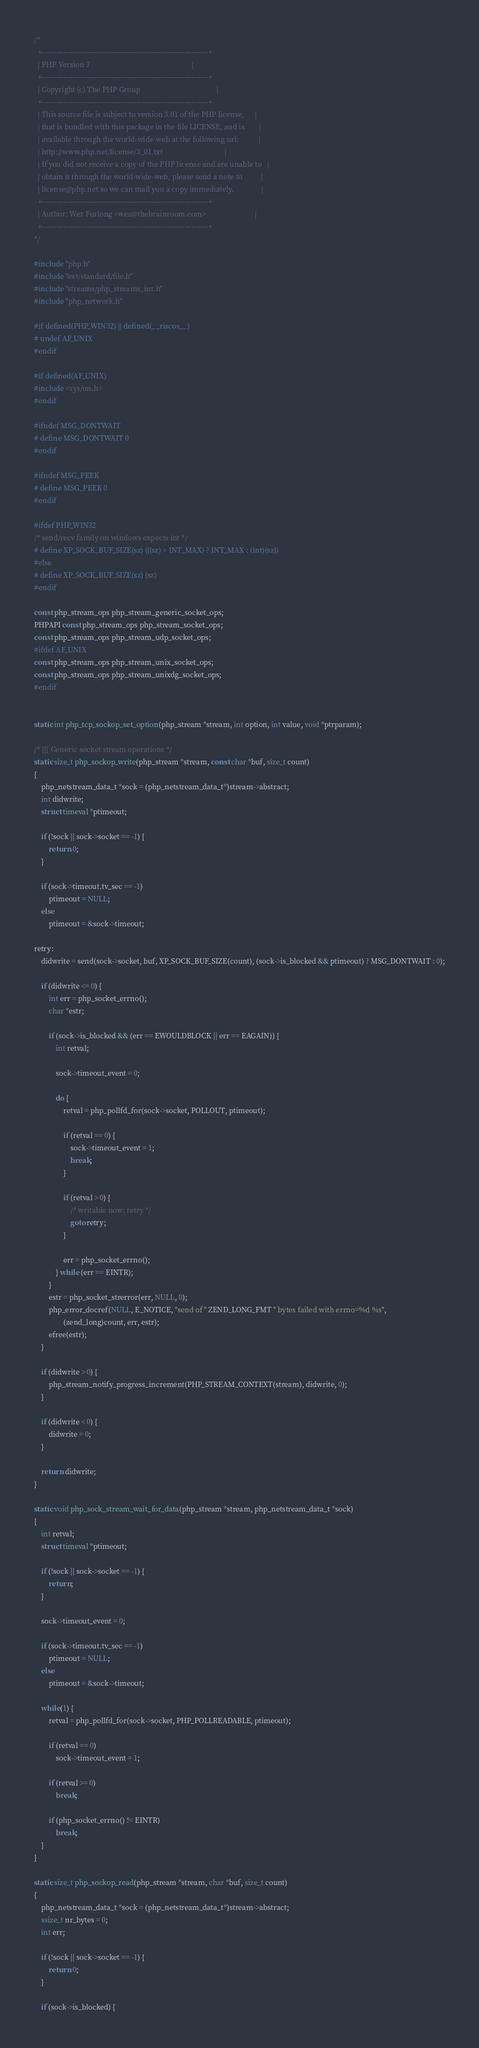<code> <loc_0><loc_0><loc_500><loc_500><_C_>/*
  +----------------------------------------------------------------------+
  | PHP Version 7                                                        |
  +----------------------------------------------------------------------+
  | Copyright (c) The PHP Group                                          |
  +----------------------------------------------------------------------+
  | This source file is subject to version 3.01 of the PHP license,      |
  | that is bundled with this package in the file LICENSE, and is        |
  | available through the world-wide-web at the following url:           |
  | http://www.php.net/license/3_01.txt                                  |
  | If you did not receive a copy of the PHP license and are unable to   |
  | obtain it through the world-wide-web, please send a note to          |
  | license@php.net so we can mail you a copy immediately.               |
  +----------------------------------------------------------------------+
  | Author: Wez Furlong <wez@thebrainroom.com>                           |
  +----------------------------------------------------------------------+
*/

#include "php.h"
#include "ext/standard/file.h"
#include "streams/php_streams_int.h"
#include "php_network.h"

#if defined(PHP_WIN32) || defined(__riscos__)
# undef AF_UNIX
#endif

#if defined(AF_UNIX)
#include <sys/un.h>
#endif

#ifndef MSG_DONTWAIT
# define MSG_DONTWAIT 0
#endif

#ifndef MSG_PEEK
# define MSG_PEEK 0
#endif

#ifdef PHP_WIN32
/* send/recv family on windows expects int */
# define XP_SOCK_BUF_SIZE(sz) (((sz) > INT_MAX) ? INT_MAX : (int)(sz))
#else
# define XP_SOCK_BUF_SIZE(sz) (sz)
#endif

const php_stream_ops php_stream_generic_socket_ops;
PHPAPI const php_stream_ops php_stream_socket_ops;
const php_stream_ops php_stream_udp_socket_ops;
#ifdef AF_UNIX
const php_stream_ops php_stream_unix_socket_ops;
const php_stream_ops php_stream_unixdg_socket_ops;
#endif


static int php_tcp_sockop_set_option(php_stream *stream, int option, int value, void *ptrparam);

/* {{{ Generic socket stream operations */
static size_t php_sockop_write(php_stream *stream, const char *buf, size_t count)
{
	php_netstream_data_t *sock = (php_netstream_data_t*)stream->abstract;
	int didwrite;
	struct timeval *ptimeout;

	if (!sock || sock->socket == -1) {
		return 0;
	}

	if (sock->timeout.tv_sec == -1)
		ptimeout = NULL;
	else
		ptimeout = &sock->timeout;

retry:
	didwrite = send(sock->socket, buf, XP_SOCK_BUF_SIZE(count), (sock->is_blocked && ptimeout) ? MSG_DONTWAIT : 0);

	if (didwrite <= 0) {
		int err = php_socket_errno();
		char *estr;

		if (sock->is_blocked && (err == EWOULDBLOCK || err == EAGAIN)) {
			int retval;

			sock->timeout_event = 0;

			do {
				retval = php_pollfd_for(sock->socket, POLLOUT, ptimeout);

				if (retval == 0) {
					sock->timeout_event = 1;
					break;
				}

				if (retval > 0) {
					/* writable now; retry */
					goto retry;
				}

				err = php_socket_errno();
			} while (err == EINTR);
		}
		estr = php_socket_strerror(err, NULL, 0);
		php_error_docref(NULL, E_NOTICE, "send of " ZEND_LONG_FMT " bytes failed with errno=%d %s",
				(zend_long)count, err, estr);
		efree(estr);
	}

	if (didwrite > 0) {
		php_stream_notify_progress_increment(PHP_STREAM_CONTEXT(stream), didwrite, 0);
	}

	if (didwrite < 0) {
		didwrite = 0;
	}

	return didwrite;
}

static void php_sock_stream_wait_for_data(php_stream *stream, php_netstream_data_t *sock)
{
	int retval;
	struct timeval *ptimeout;

	if (!sock || sock->socket == -1) {
		return;
	}

	sock->timeout_event = 0;

	if (sock->timeout.tv_sec == -1)
		ptimeout = NULL;
	else
		ptimeout = &sock->timeout;

	while(1) {
		retval = php_pollfd_for(sock->socket, PHP_POLLREADABLE, ptimeout);

		if (retval == 0)
			sock->timeout_event = 1;

		if (retval >= 0)
			break;

		if (php_socket_errno() != EINTR)
			break;
	}
}

static size_t php_sockop_read(php_stream *stream, char *buf, size_t count)
{
	php_netstream_data_t *sock = (php_netstream_data_t*)stream->abstract;
	ssize_t nr_bytes = 0;
	int err;

	if (!sock || sock->socket == -1) {
		return 0;
	}

	if (sock->is_blocked) {</code> 